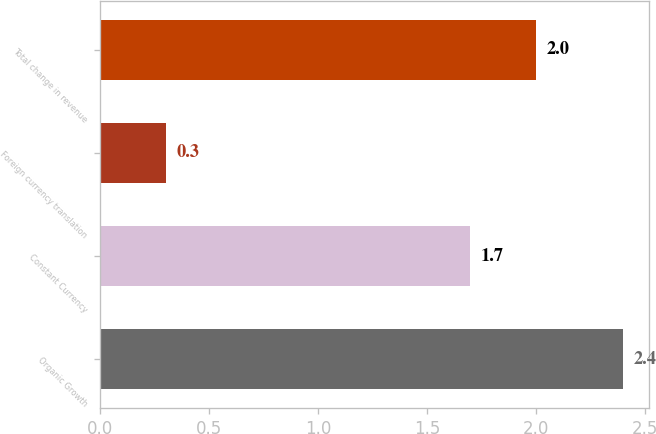Convert chart to OTSL. <chart><loc_0><loc_0><loc_500><loc_500><bar_chart><fcel>Organic Growth<fcel>Constant Currency<fcel>Foreign currency translation<fcel>Total change in revenue<nl><fcel>2.4<fcel>1.7<fcel>0.3<fcel>2<nl></chart> 